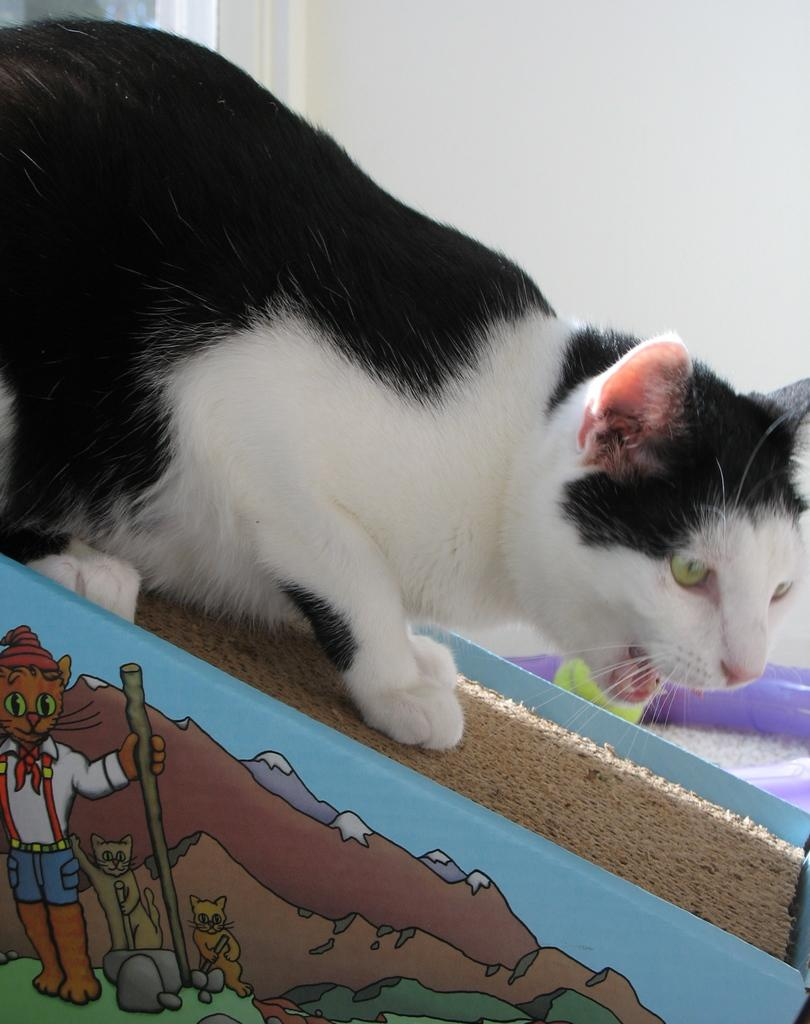What type of animal is in the image? There is a cat in the image. What colors can be seen on the cat? The cat is black and white in color. Where is the cat located in the image? The cat is on a surface. What else can be seen in the image besides the cat? There are paintings in the image. What is visible in the background of the image? There is a wall in the background of the image. What type of error can be seen in the book in the image? There is no book present in the image, so it is not possible to determine if there is an error or not. 